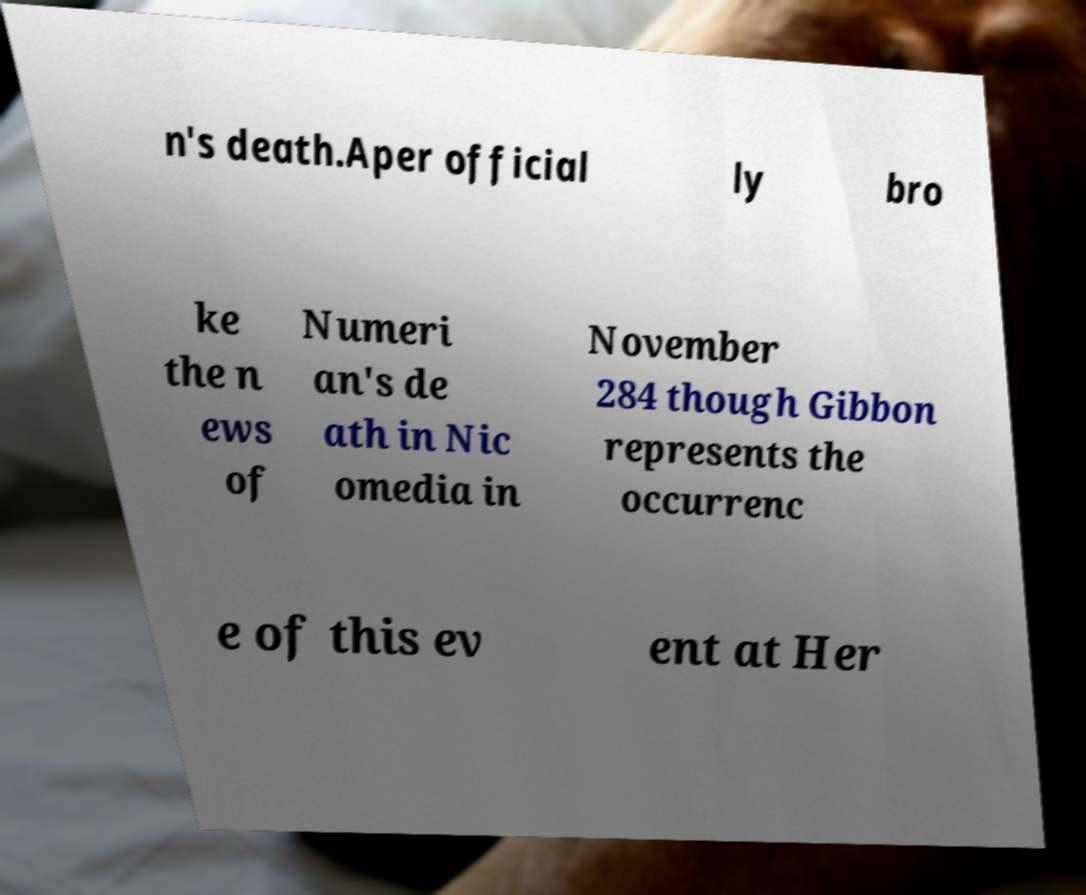Please identify and transcribe the text found in this image. n's death.Aper official ly bro ke the n ews of Numeri an's de ath in Nic omedia in November 284 though Gibbon represents the occurrenc e of this ev ent at Her 